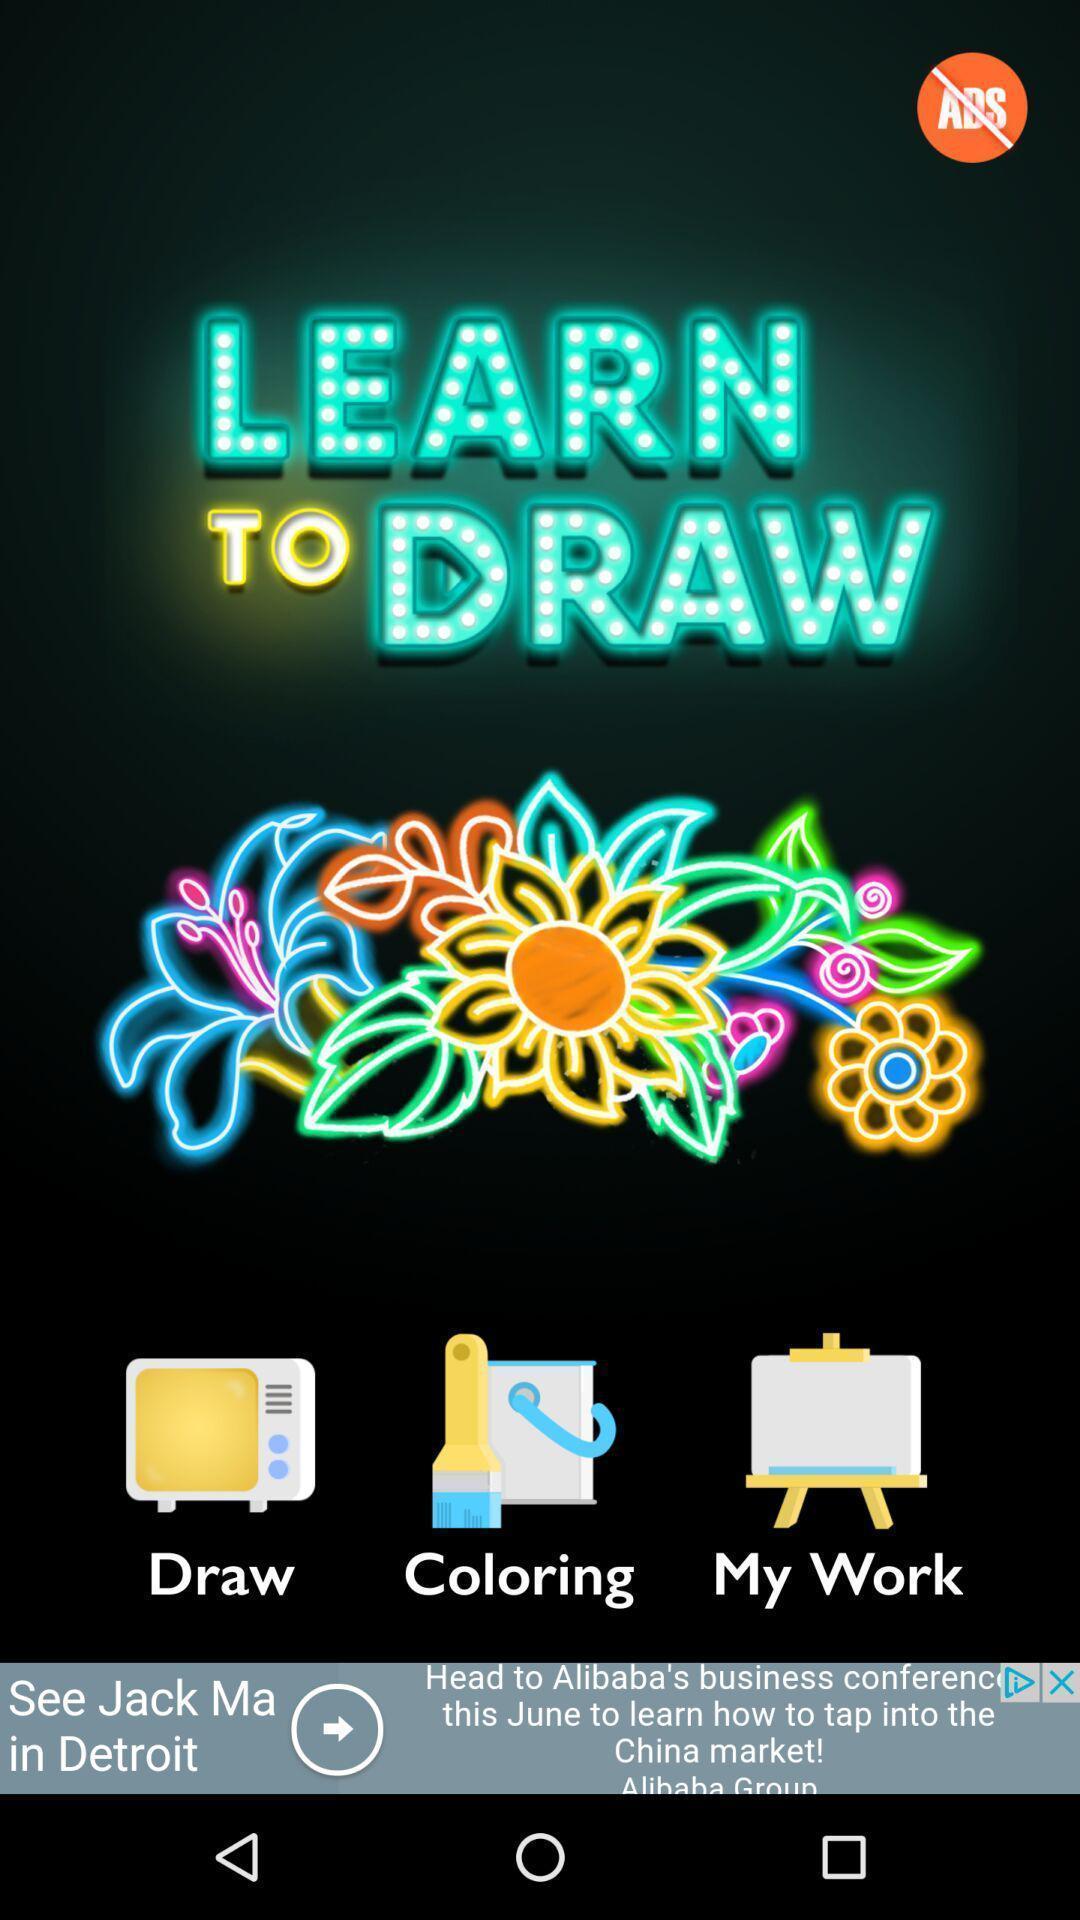What is the overall content of this screenshot? Screen displaying page of an drawing application. 